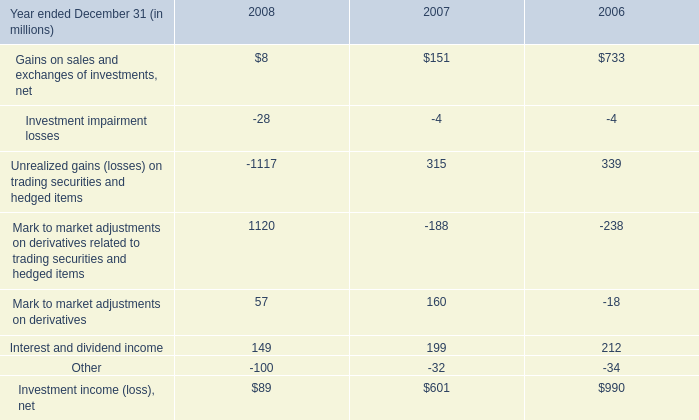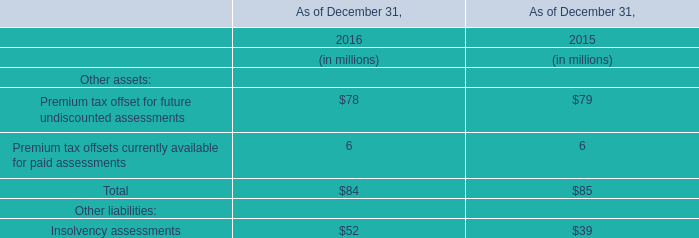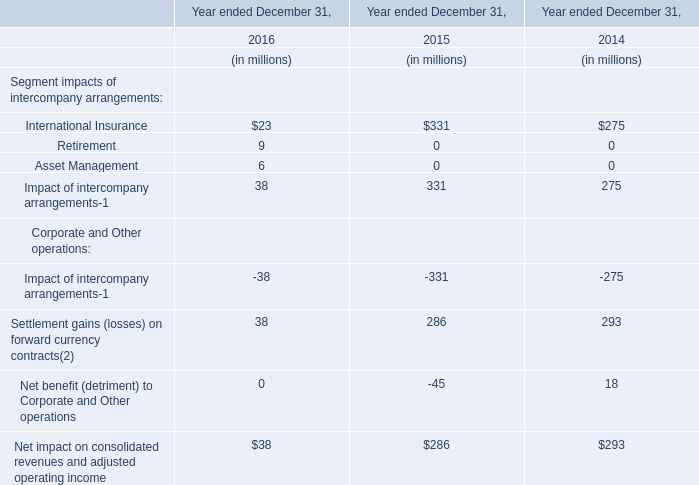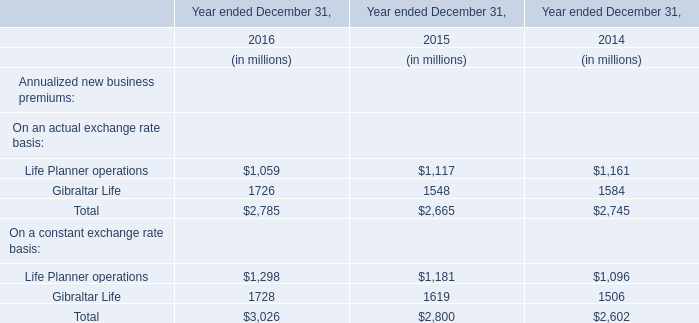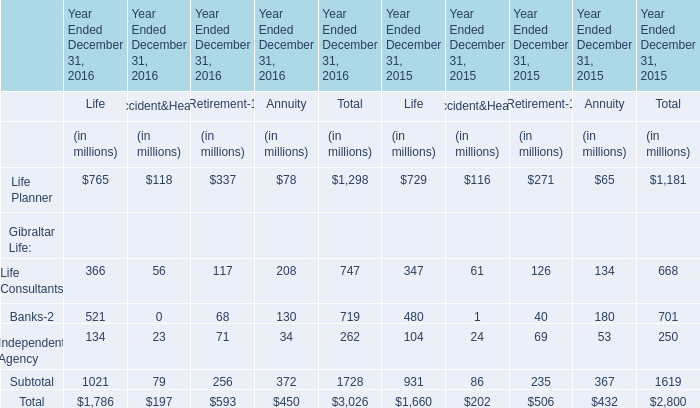In which year ended December 31 is the premiums of the Gibraltar Life on an actual exchange rate basis the least? 
Answer: 2015. 